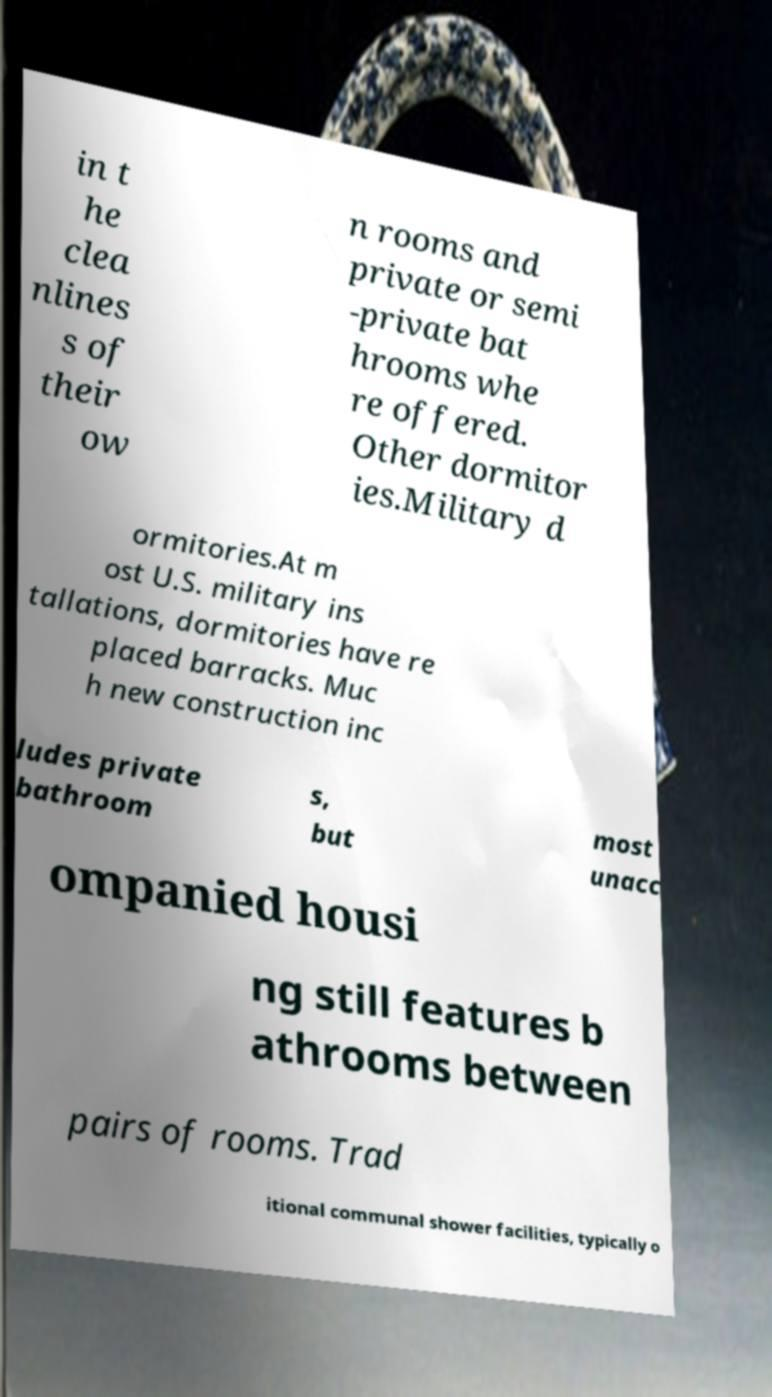Can you read and provide the text displayed in the image?This photo seems to have some interesting text. Can you extract and type it out for me? in t he clea nlines s of their ow n rooms and private or semi -private bat hrooms whe re offered. Other dormitor ies.Military d ormitories.At m ost U.S. military ins tallations, dormitories have re placed barracks. Muc h new construction inc ludes private bathroom s, but most unacc ompanied housi ng still features b athrooms between pairs of rooms. Trad itional communal shower facilities, typically o 